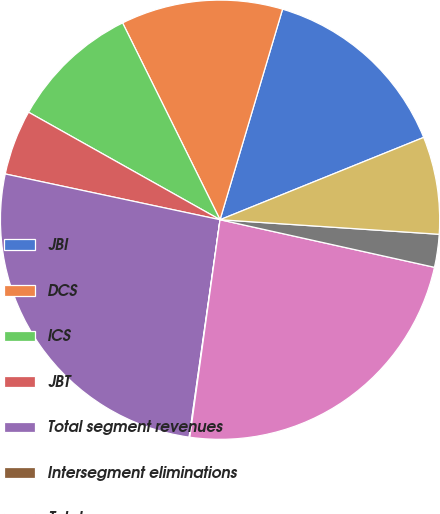Convert chart to OTSL. <chart><loc_0><loc_0><loc_500><loc_500><pie_chart><fcel>JBI<fcel>DCS<fcel>ICS<fcel>JBT<fcel>Total segment revenues<fcel>Intersegment eliminations<fcel>Total<fcel>Other<fcel>T otal<nl><fcel>14.29%<fcel>11.91%<fcel>9.54%<fcel>4.8%<fcel>26.09%<fcel>0.05%<fcel>23.72%<fcel>2.42%<fcel>7.17%<nl></chart> 